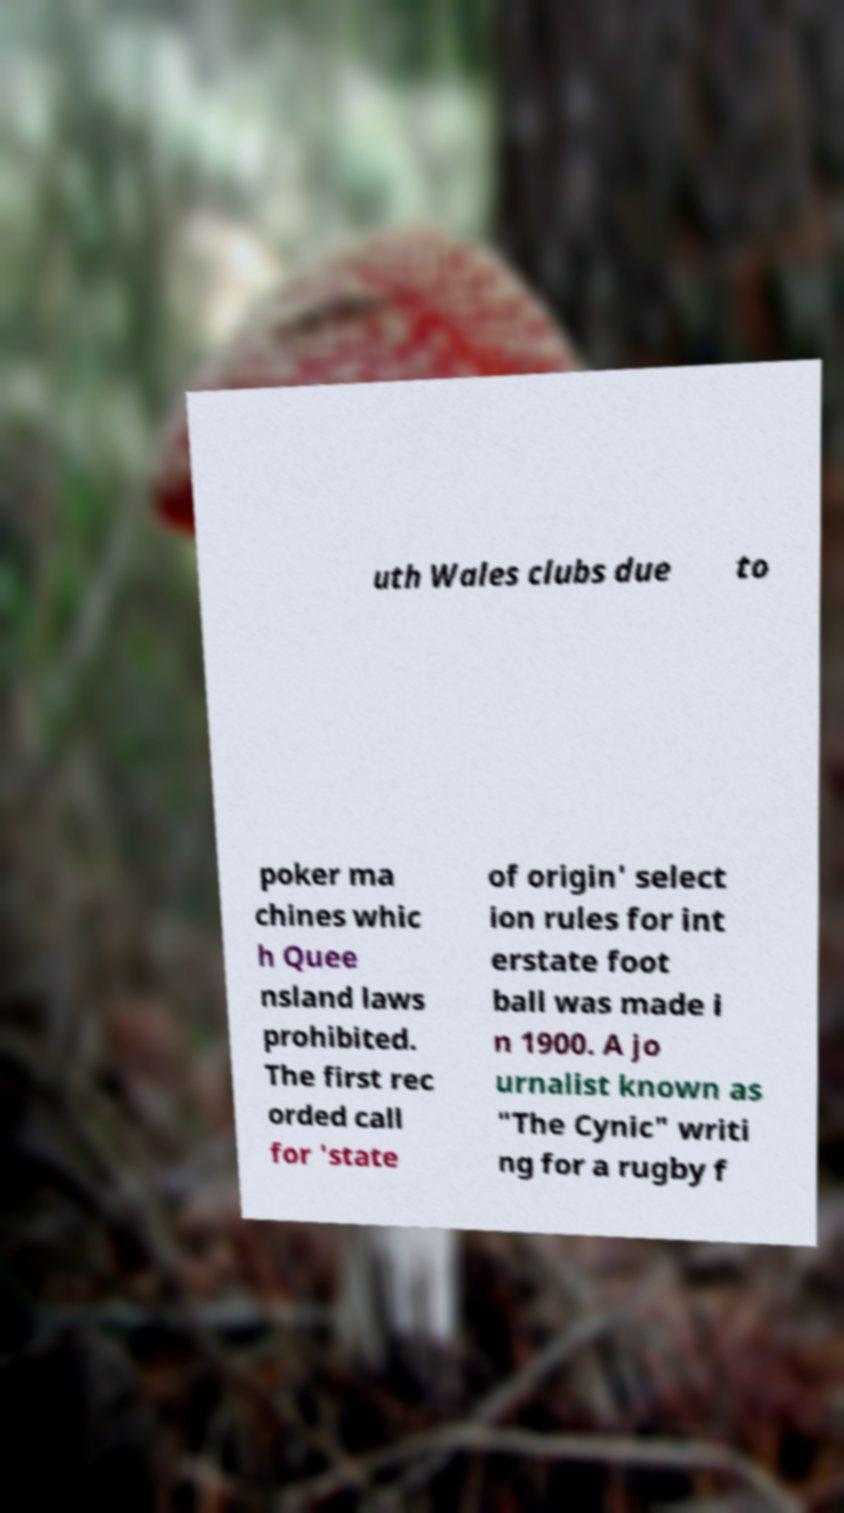Please identify and transcribe the text found in this image. uth Wales clubs due to poker ma chines whic h Quee nsland laws prohibited. The first rec orded call for 'state of origin' select ion rules for int erstate foot ball was made i n 1900. A jo urnalist known as "The Cynic" writi ng for a rugby f 